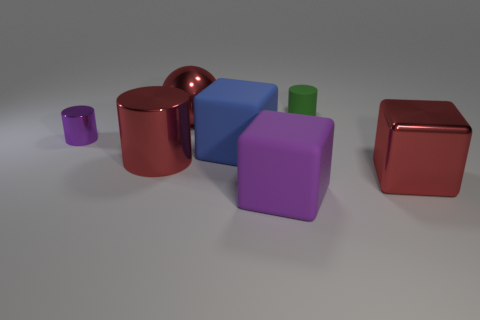Is the number of big blue things greater than the number of tiny cyan metal cubes?
Offer a very short reply. Yes. There is a red shiny cylinder that is in front of the matte cylinder; is it the same size as the large purple cube?
Keep it short and to the point. Yes. What number of cubes are the same color as the large shiny sphere?
Give a very brief answer. 1. Do the small green object and the purple shiny thing have the same shape?
Give a very brief answer. Yes. There is another red object that is the same shape as the tiny metallic thing; what is its size?
Make the answer very short. Large. Is the number of tiny rubber cylinders that are right of the large metal cylinder greater than the number of big blocks that are behind the tiny purple object?
Your answer should be very brief. Yes. Are the large red ball and the block that is in front of the big red block made of the same material?
Offer a very short reply. No. There is a rubber object that is both in front of the tiny purple metal object and on the right side of the blue cube; what is its color?
Ensure brevity in your answer.  Purple. What is the shape of the large red object that is behind the blue matte cube?
Your response must be concise. Sphere. There is a purple thing in front of the purple cylinder on the left side of the block that is to the right of the green cylinder; what size is it?
Offer a terse response. Large. 